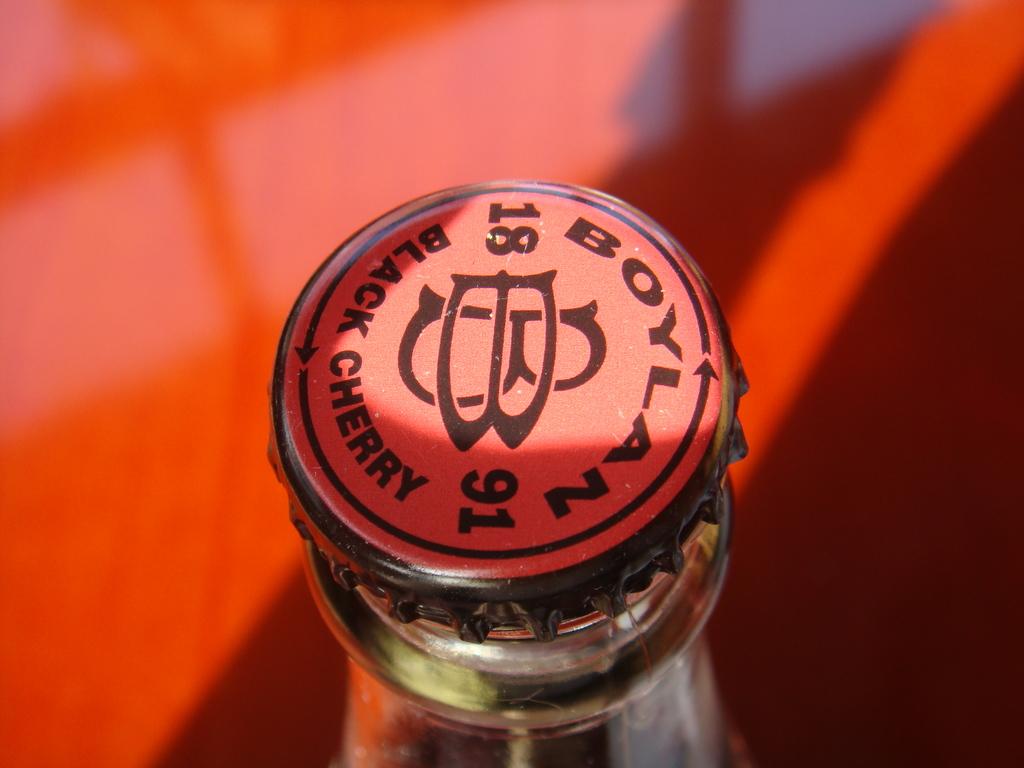What number is on the cap?
Your answer should be compact. 1891. 